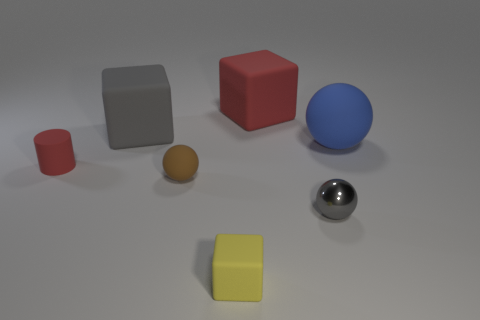Add 2 big blue matte cylinders. How many objects exist? 9 Subtract all blocks. How many objects are left? 4 Add 4 small gray things. How many small gray things are left? 5 Add 6 tiny green metal things. How many tiny green metal things exist? 6 Subtract 0 cyan blocks. How many objects are left? 7 Subtract all big purple cylinders. Subtract all tiny red rubber cylinders. How many objects are left? 6 